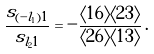<formula> <loc_0><loc_0><loc_500><loc_500>\frac { s _ { ( - l _ { 1 } ) 1 } } { s _ { l _ { 2 } 1 } } = - \frac { \langle 1 6 \rangle \langle 2 3 \rangle } { \langle 2 6 \rangle \langle 1 3 \rangle } \, .</formula> 